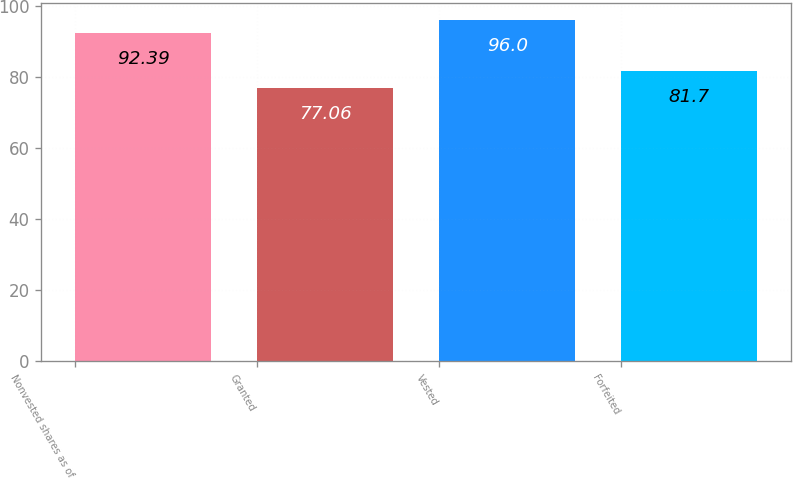Convert chart to OTSL. <chart><loc_0><loc_0><loc_500><loc_500><bar_chart><fcel>Nonvested shares as of<fcel>Granted<fcel>Vested<fcel>Forfeited<nl><fcel>92.39<fcel>77.06<fcel>96<fcel>81.7<nl></chart> 